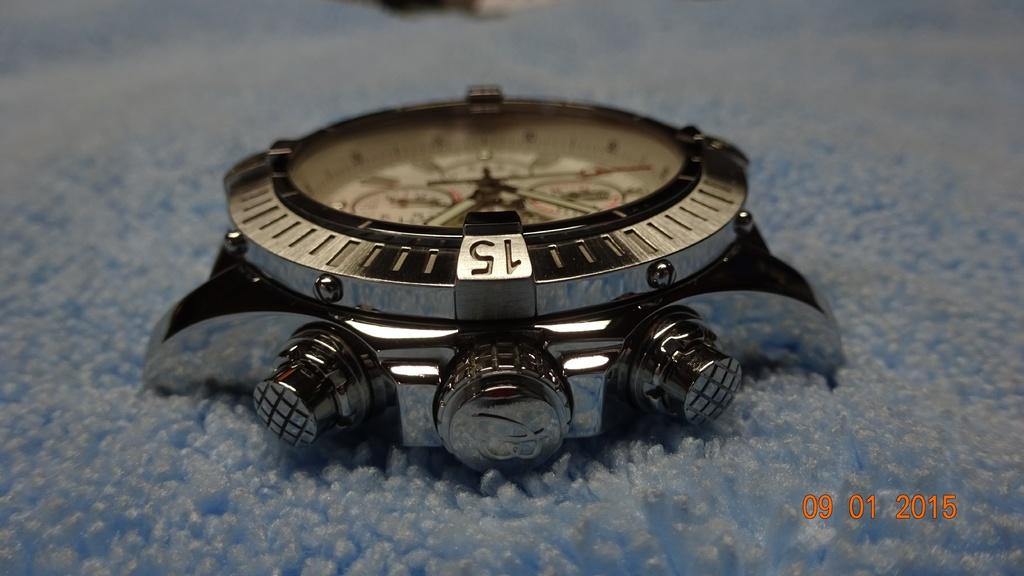<image>
Render a clear and concise summary of the photo. Face of a watch which has the number 15 on the bottom. 